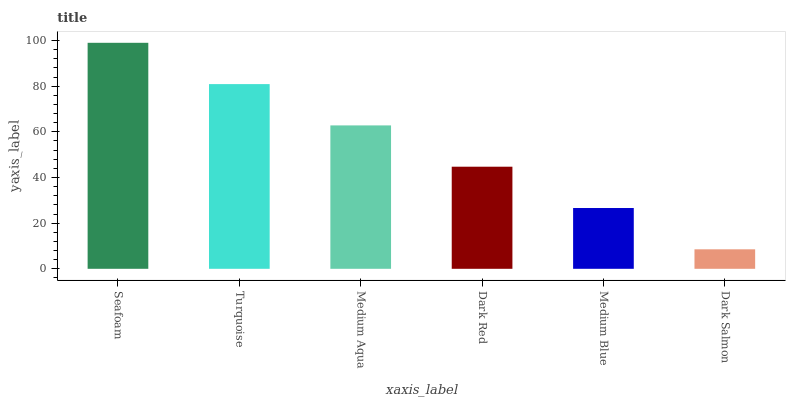Is Dark Salmon the minimum?
Answer yes or no. Yes. Is Seafoam the maximum?
Answer yes or no. Yes. Is Turquoise the minimum?
Answer yes or no. No. Is Turquoise the maximum?
Answer yes or no. No. Is Seafoam greater than Turquoise?
Answer yes or no. Yes. Is Turquoise less than Seafoam?
Answer yes or no. Yes. Is Turquoise greater than Seafoam?
Answer yes or no. No. Is Seafoam less than Turquoise?
Answer yes or no. No. Is Medium Aqua the high median?
Answer yes or no. Yes. Is Dark Red the low median?
Answer yes or no. Yes. Is Medium Blue the high median?
Answer yes or no. No. Is Dark Salmon the low median?
Answer yes or no. No. 